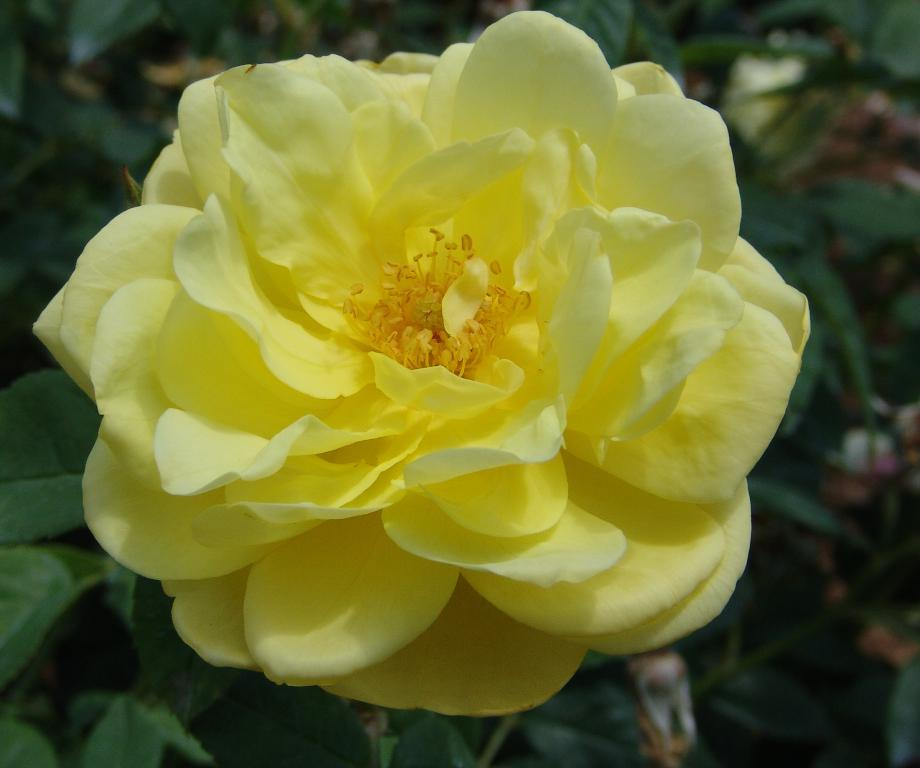What type of plant is featured in the image? There is a plant in the image, and it has a yellow rose. Are there any other plants visible in the image? Yes, there are other plants in the background of the image. What color are the leaves of the background plants? The background plants have green leaves. Can you tell me how many yams are growing in the field in the image? There is no field or yams present in the image; it features a plant with a yellow rose and other plants in the background. 